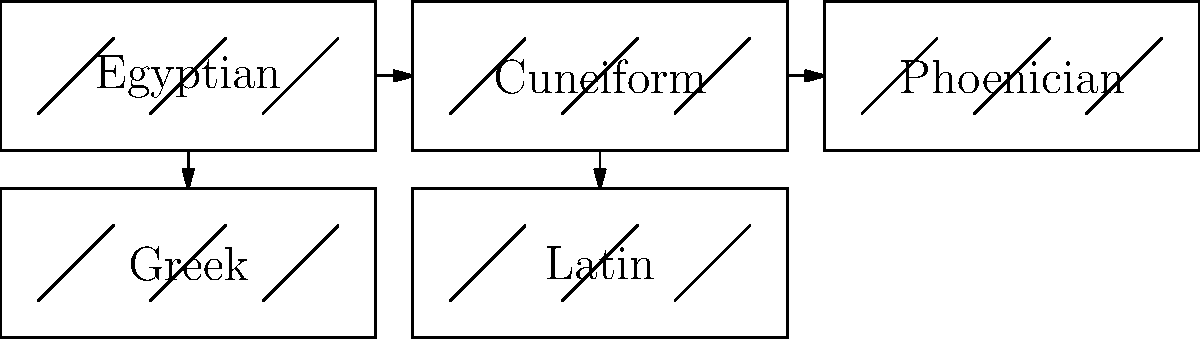As an archaeology documentary host, you're presenting a segment on the evolution of writing systems. Based on the visual representation above, which writing system played a crucial role in bridging the gap between ancient pictographic scripts and the modern alphabets used today? To answer this question, let's analyze the evolution of writing systems as shown in the diagram:

1. Egyptian hieroglyphs: One of the earliest writing systems, using pictorial symbols.

2. Cuneiform: Developed in Mesopotamia, using wedge-shaped marks on clay tablets.

3. Phoenician alphabet: A key development in writing systems, introducing a simplified set of characters representing sounds rather than concepts.

4. Greek alphabet: Adapted from the Phoenician system, adding vowels and standardizing the direction of writing.

5. Latin alphabet: Derived from the Greek alphabet, forming the basis for many modern writing systems.

The crucial bridge between ancient pictographic scripts and modern alphabets is the Phoenician alphabet. This system marks a significant transition for several reasons:

1. Simplification: It reduced the number of characters from hundreds or thousands to about 22.

2. Abstraction: The characters became more abstract, moving away from pictorial representations.

3. Sound-based: Each character represented a specific sound (consonant) rather than a whole word or concept.

4. Adaptability: Its simplicity and efficiency made it easy to adapt to other languages, as evidenced by its influence on Greek and subsequently Latin alphabets.

5. Widespread influence: The Phoenician alphabet spread through trade routes, influencing writing systems across a large geographical area.

This transition from complex pictographic systems to a simple, sound-based alphabet was a crucial step in the development of modern writing systems, making the Phoenician alphabet the key bridge in this evolution.
Answer: Phoenician alphabet 